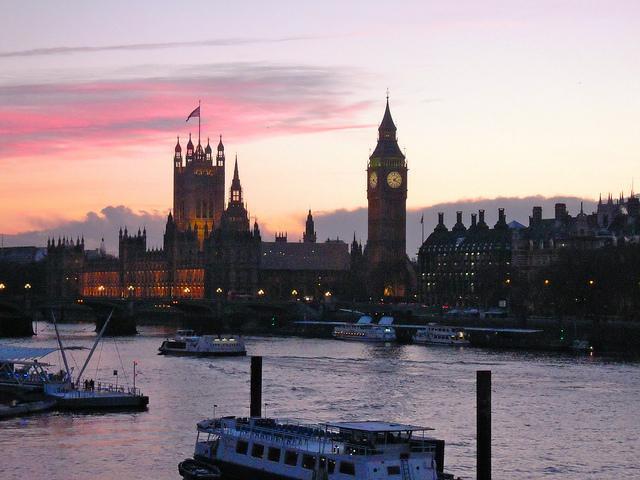How many boats are in the photo?
Give a very brief answer. 2. How many orange ropescables are attached to the clock?
Give a very brief answer. 0. 